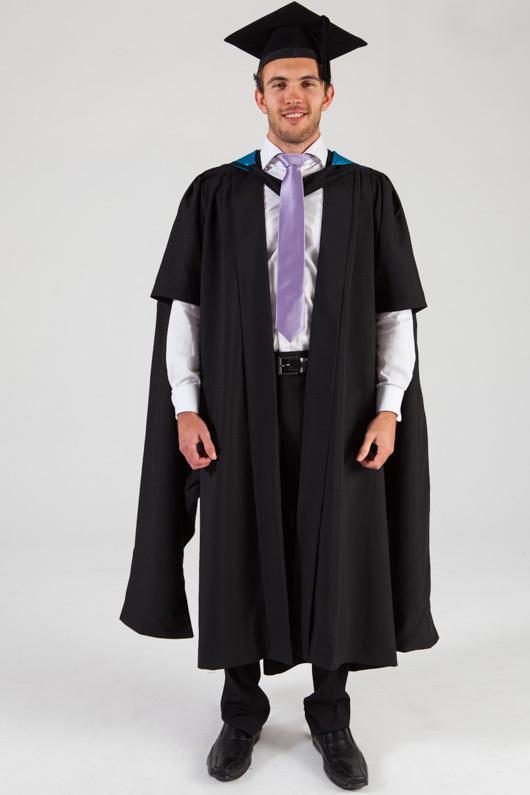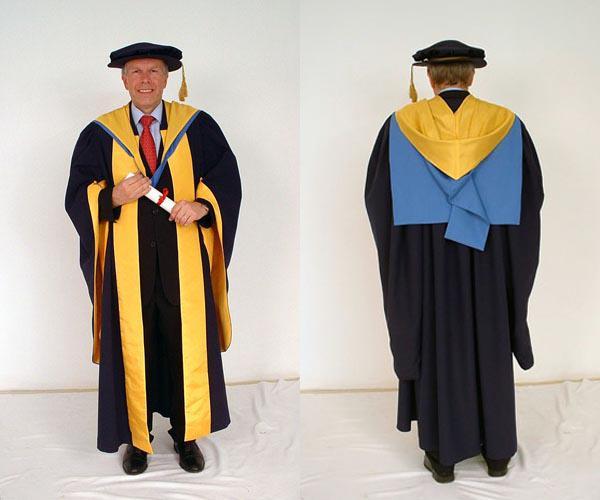The first image is the image on the left, the second image is the image on the right. For the images displayed, is the sentence "There are exactly two people shown in both of the images." factually correct? Answer yes or no. No. 